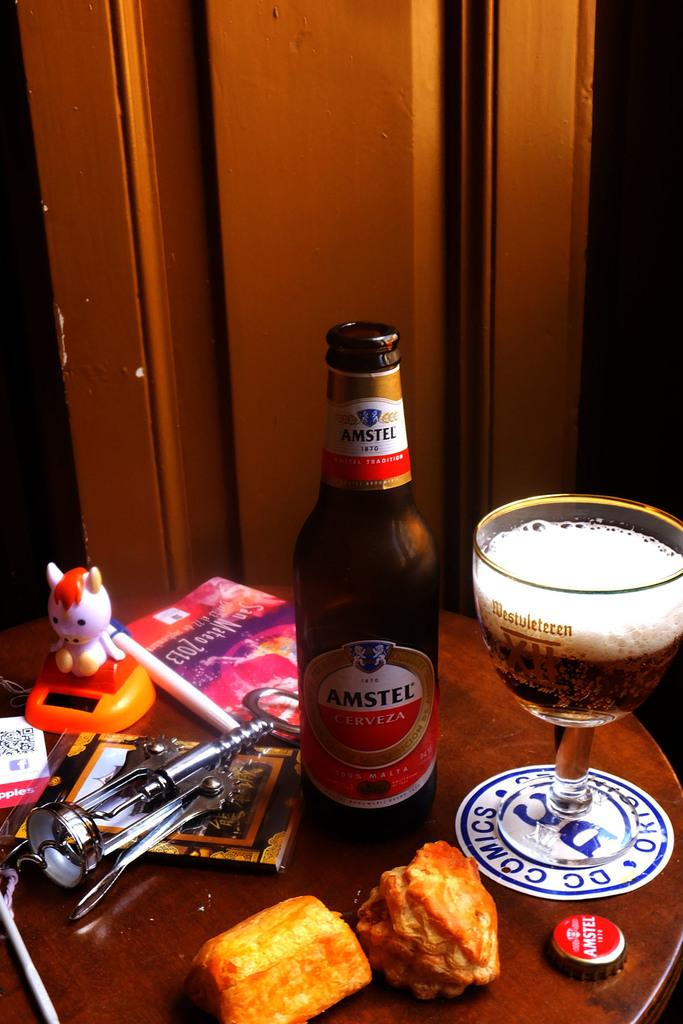<image>
Summarize the visual content of the image. A bottle of Amstel sits on a round table. 